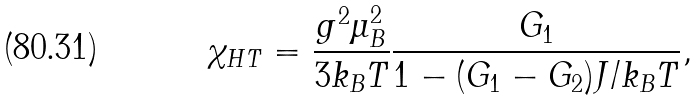<formula> <loc_0><loc_0><loc_500><loc_500>\chi _ { H T } = \frac { g ^ { 2 } \mu _ { B } ^ { 2 } } { 3 k _ { B } T } \frac { G _ { 1 } } { 1 - ( G _ { 1 } - G _ { 2 } ) J / k _ { B } T } ,</formula> 